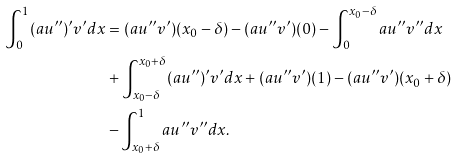<formula> <loc_0><loc_0><loc_500><loc_500>\int _ { 0 } ^ { 1 } ( a u ^ { \prime \prime } ) ^ { \prime } v ^ { \prime } d x & = ( a u ^ { \prime \prime } v ^ { \prime } ) ( x _ { 0 } - \delta ) - ( a u ^ { \prime \prime } v ^ { \prime } ) ( 0 ) - \int _ { 0 } ^ { x _ { 0 } - \delta } a u ^ { \prime \prime } v ^ { \prime \prime } d x \\ & + \int _ { x _ { 0 } - \delta } ^ { x _ { 0 } + \delta } ( a u ^ { \prime \prime } ) ^ { \prime } v ^ { \prime } d x + ( a u ^ { \prime \prime } v ^ { \prime } ) ( 1 ) - ( a u ^ { \prime \prime } v ^ { \prime } ) ( x _ { 0 } + \delta ) \\ & - \int _ { x _ { 0 } + \delta } ^ { 1 } a u ^ { \prime \prime } v ^ { \prime \prime } d x .</formula> 